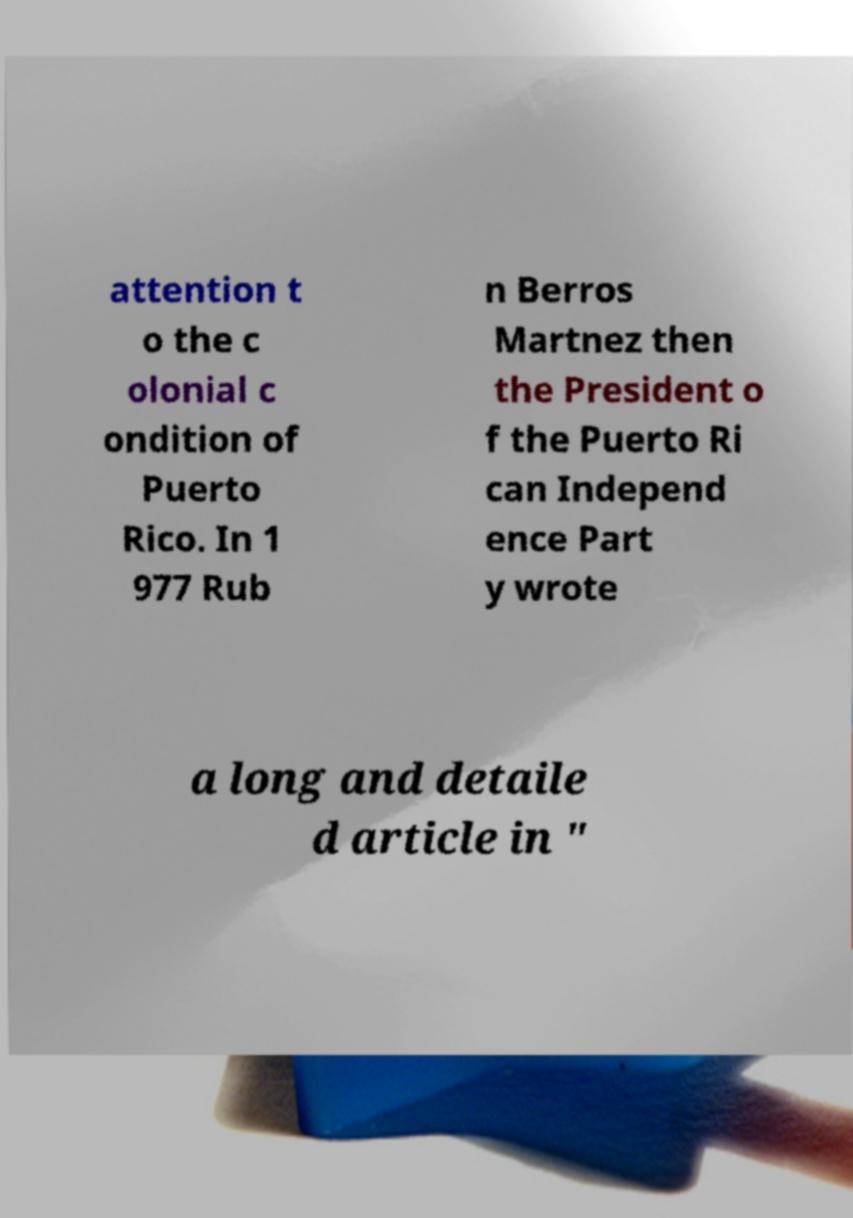Please identify and transcribe the text found in this image. attention t o the c olonial c ondition of Puerto Rico. In 1 977 Rub n Berros Martnez then the President o f the Puerto Ri can Independ ence Part y wrote a long and detaile d article in " 